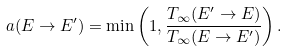Convert formula to latex. <formula><loc_0><loc_0><loc_500><loc_500>a ( E \to E ^ { \prime } ) = \min \left ( 1 , \frac { T _ { \infty } ( E ^ { \prime } \to E ) } { T _ { \infty } ( E \to E ^ { \prime } ) } \right ) .</formula> 